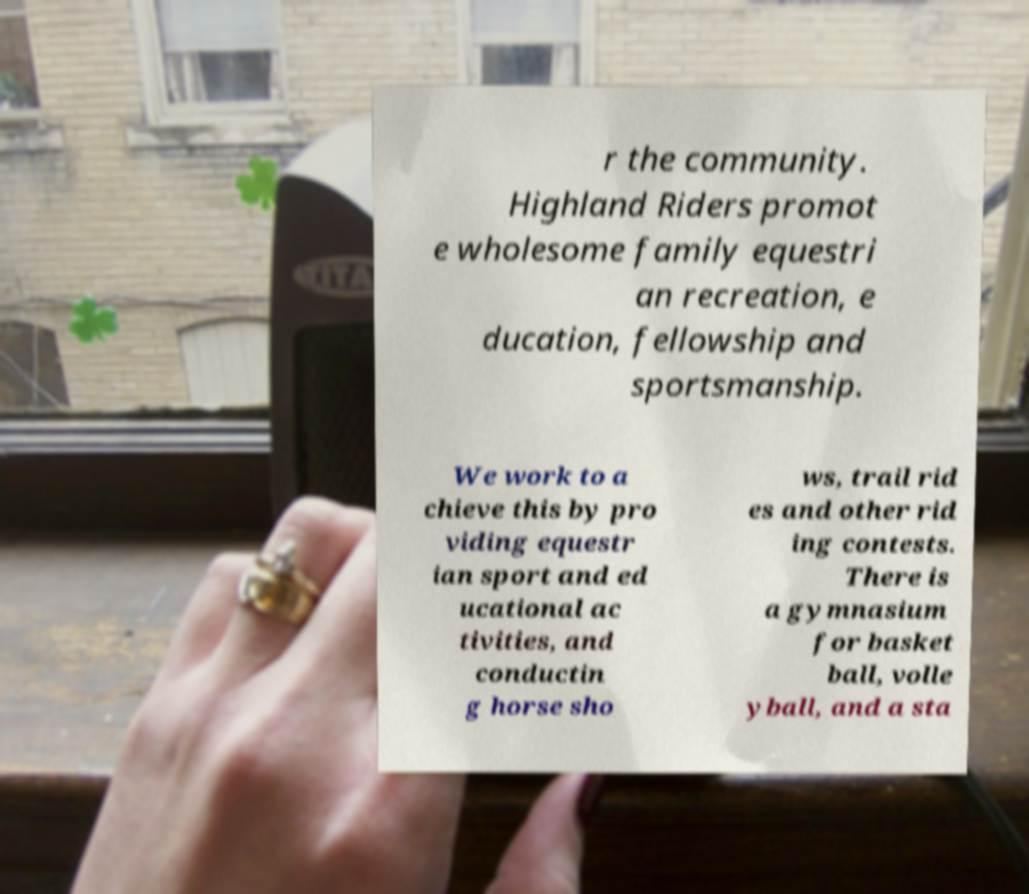Please identify and transcribe the text found in this image. r the community. Highland Riders promot e wholesome family equestri an recreation, e ducation, fellowship and sportsmanship. We work to a chieve this by pro viding equestr ian sport and ed ucational ac tivities, and conductin g horse sho ws, trail rid es and other rid ing contests. There is a gymnasium for basket ball, volle yball, and a sta 